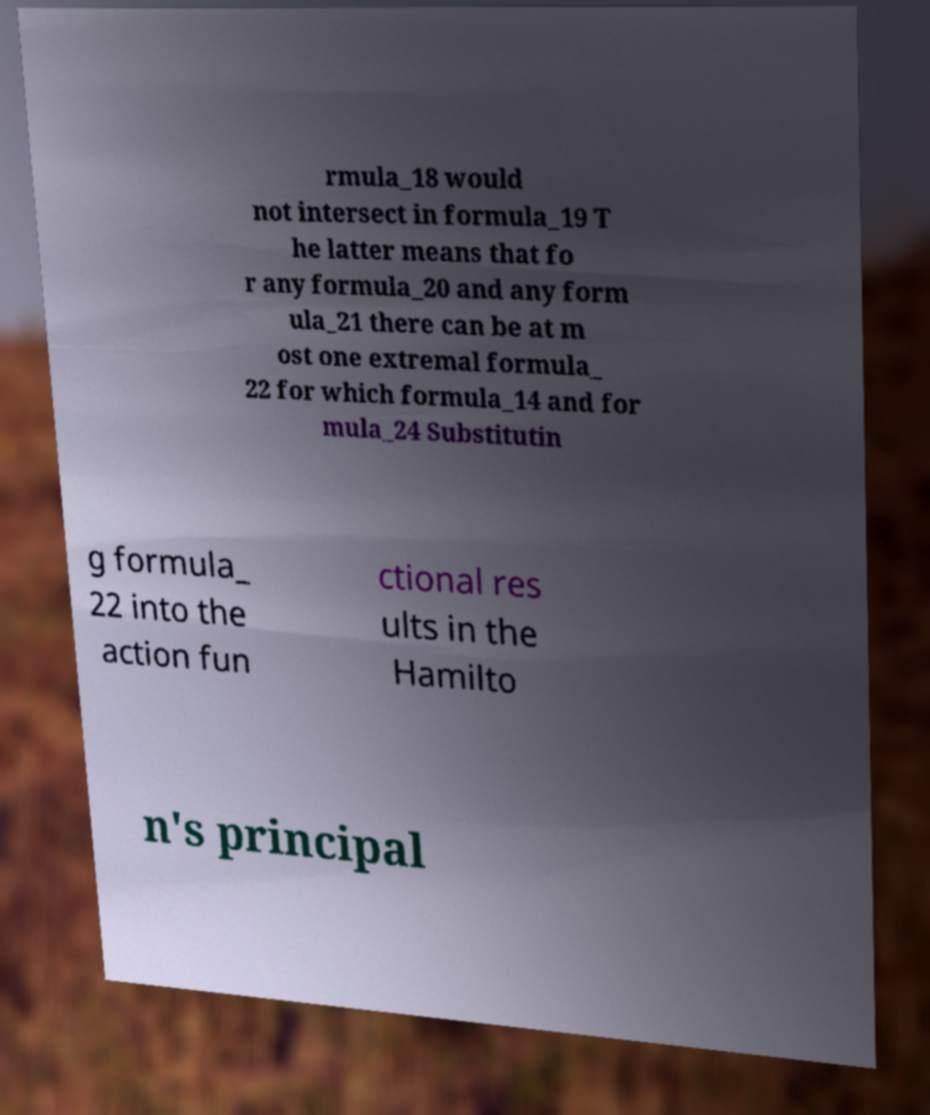Could you extract and type out the text from this image? rmula_18 would not intersect in formula_19 T he latter means that fo r any formula_20 and any form ula_21 there can be at m ost one extremal formula_ 22 for which formula_14 and for mula_24 Substitutin g formula_ 22 into the action fun ctional res ults in the Hamilto n's principal 